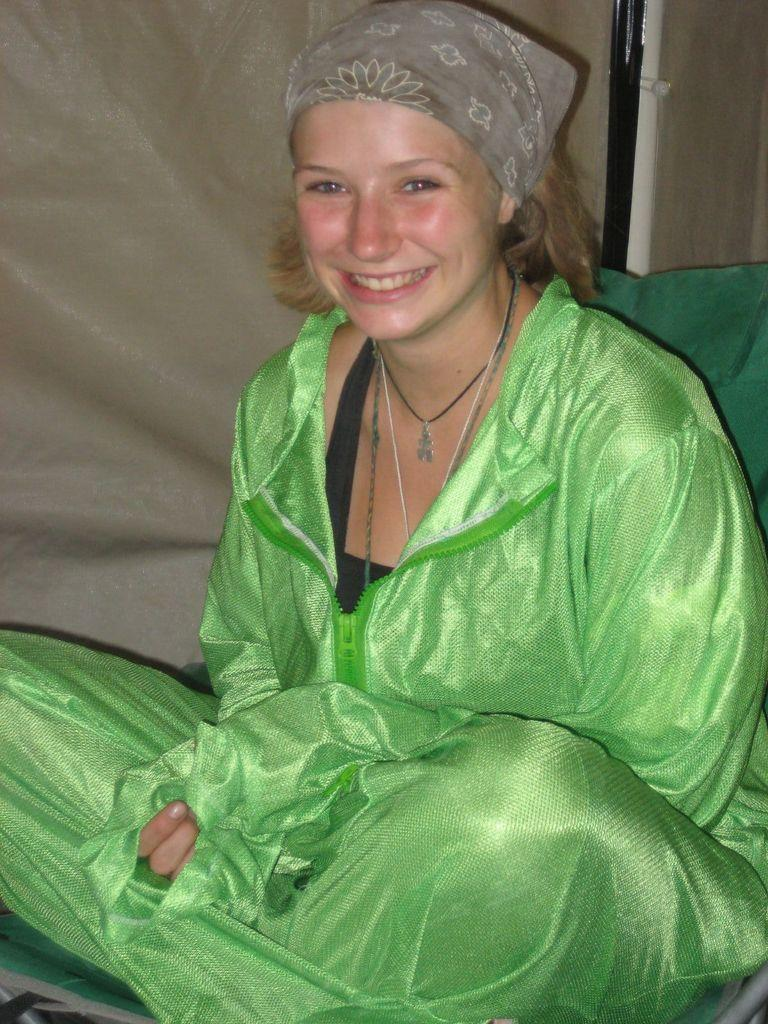Who is present in the image? There is a woman in the image. What is the woman doing in the image? The woman is sitting in the image. What is the woman's facial expression in the image? The woman is smiling in the image. What is the woman wearing in the image? The woman is wearing a green dress in the image. What can be seen in the background of the image? There is a curtain visible in the image. What color is the curtain in the image? The curtain is cream in color in the image. What type of butter is being used by the government in the image? There is no butter or government mentioned in the image; it features a woman sitting and smiling while wearing a green dress, with a cream-colored curtain in the background. 